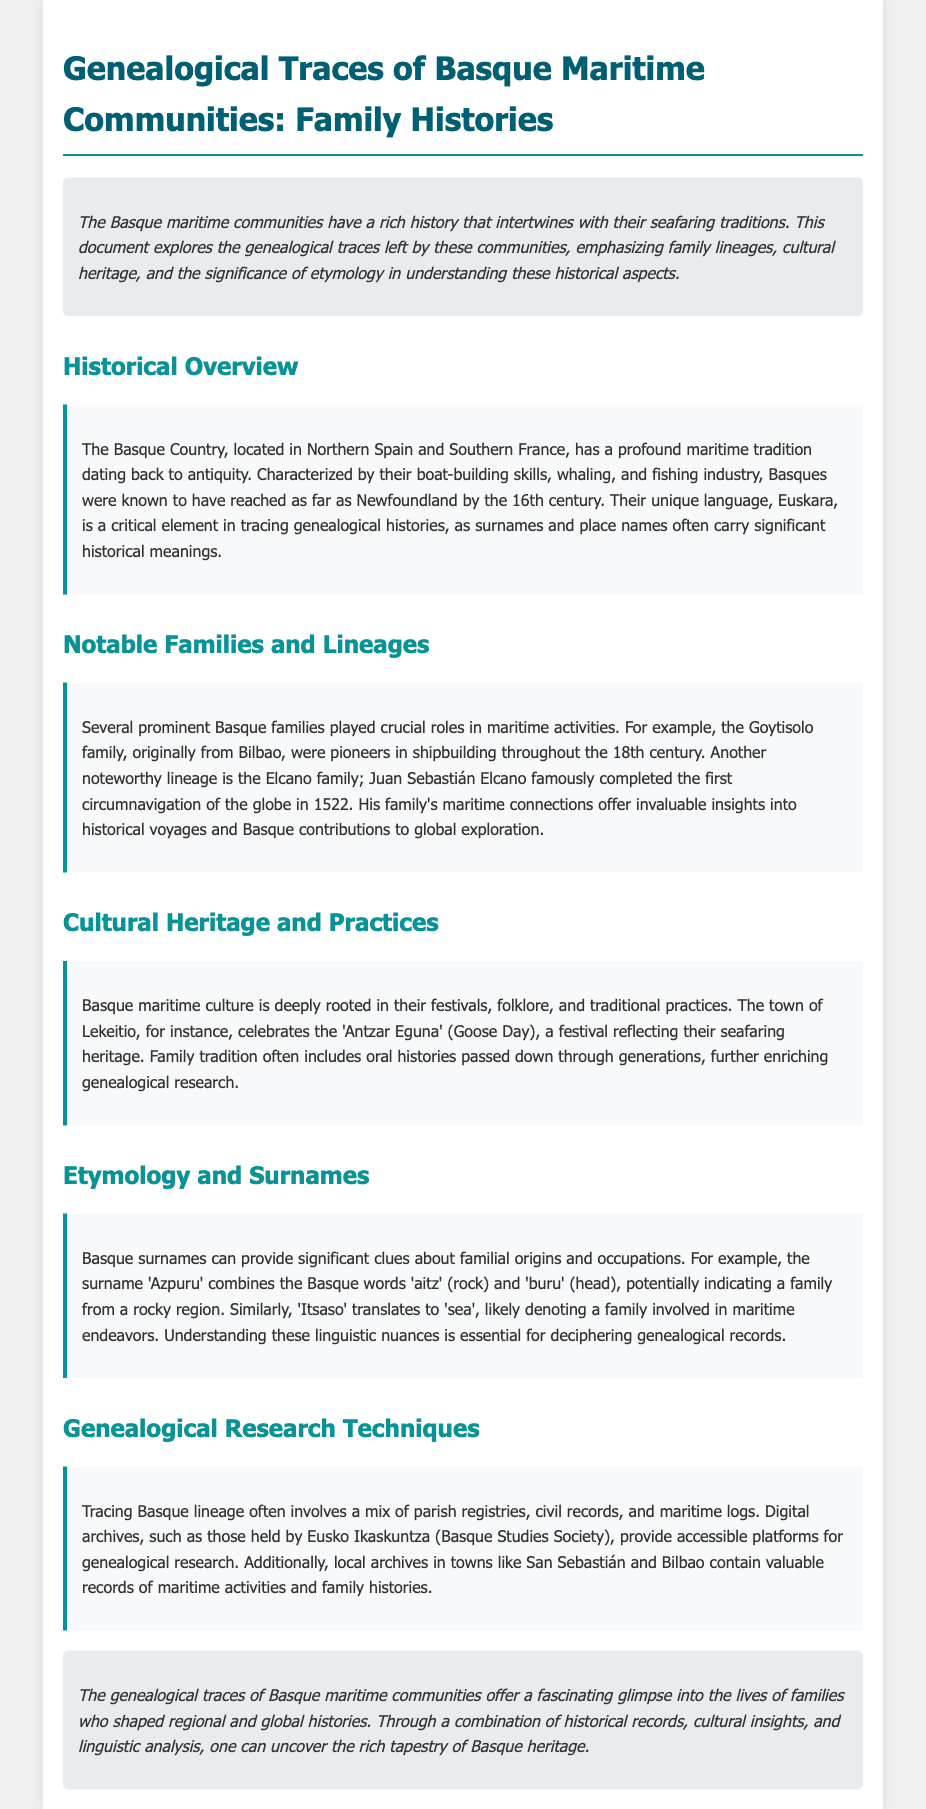What is the main focus of the document? The main focus of the document is the genealogical traces left by Basque maritime communities, their family lineages, cultural heritage, and the significance of etymology.
Answer: Genealogical traces of Basque maritime communities When did Juan Sebastián Elcano complete the first circumnavigation of the globe? Juan Sebastián Elcano completed the first circumnavigation of the globe in 1522.
Answer: 1522 What significant maritime activity was the Goytisolo family known for? The Goytisolo family were pioneers in shipbuilding throughout the 18th century.
Answer: Shipbuilding Which festival reflects Basque seafaring heritage? The festival that reflects Basque seafaring heritage is 'Antzar Eguna' (Goose Day).
Answer: Antzar Eguna What are the Basque words that form the surname 'Azpuru'? The surname 'Azpuru' combines the Basque words 'aitz' (rock) and 'buru' (head).
Answer: Aitz, Buru What types of records are useful for tracing Basque lineage? Useful records for tracing Basque lineage include parish registries, civil records, and maritime logs.
Answer: Parish registries, civil records, maritime logs What organization provides digital archives for genealogical research? The organization that provides digital archives for genealogical research is Eusko Ikaskuntza (Basque Studies Society).
Answer: Eusko Ikaskuntza Which town is noted for its valuable records of maritime activities and family histories? San Sebastián is noted for its valuable records of maritime activities and family histories.
Answer: San Sebastián 